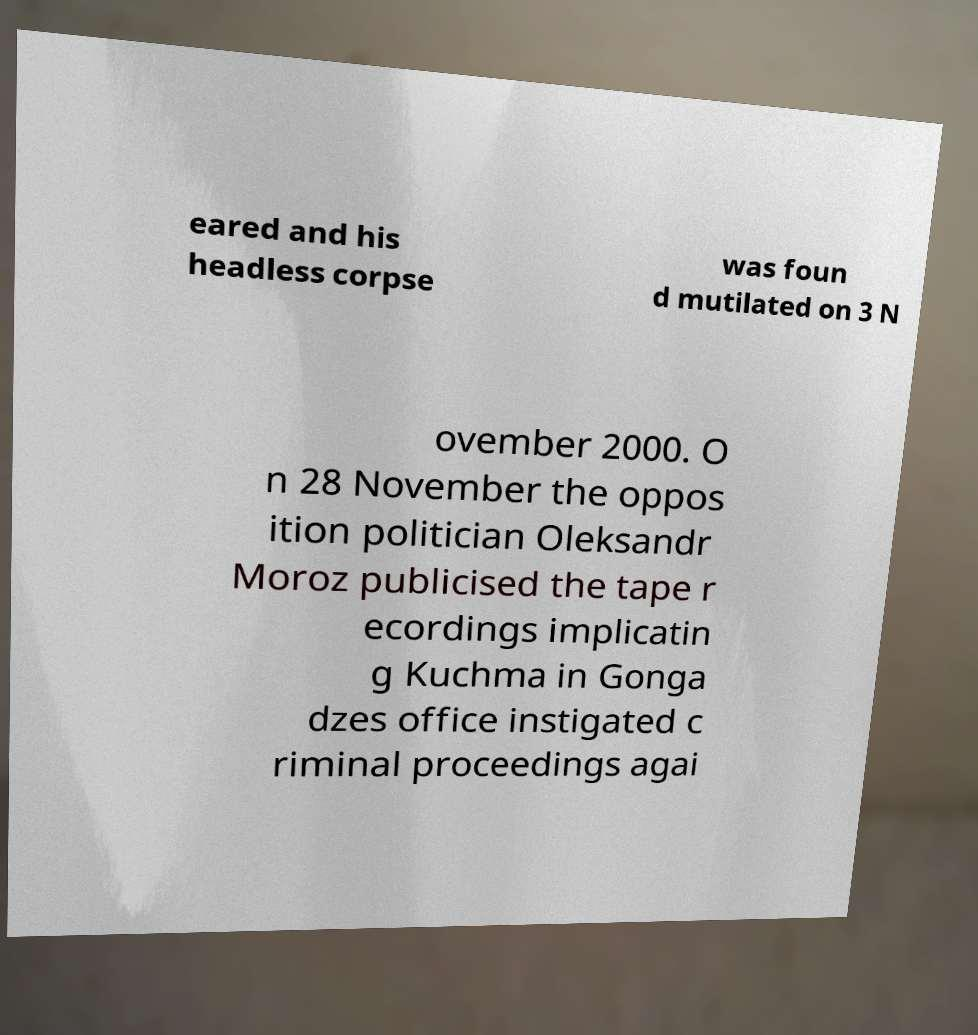Can you accurately transcribe the text from the provided image for me? eared and his headless corpse was foun d mutilated on 3 N ovember 2000. O n 28 November the oppos ition politician Oleksandr Moroz publicised the tape r ecordings implicatin g Kuchma in Gonga dzes office instigated c riminal proceedings agai 